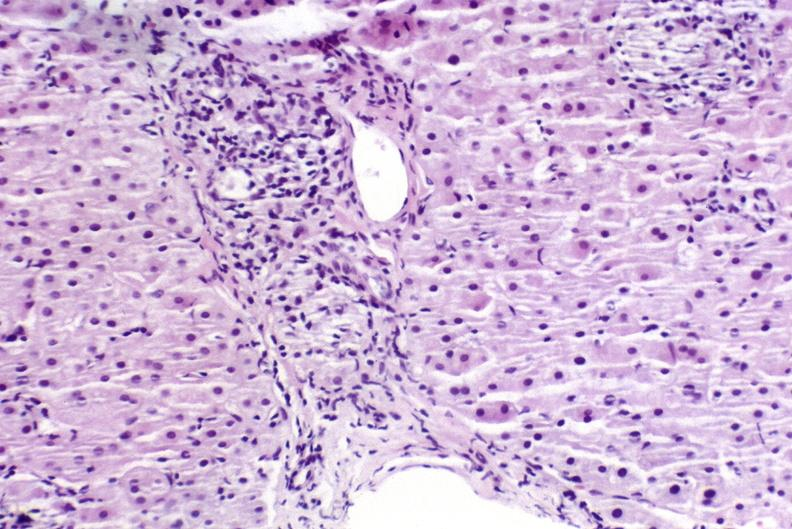s bone, clivus present?
Answer the question using a single word or phrase. No 